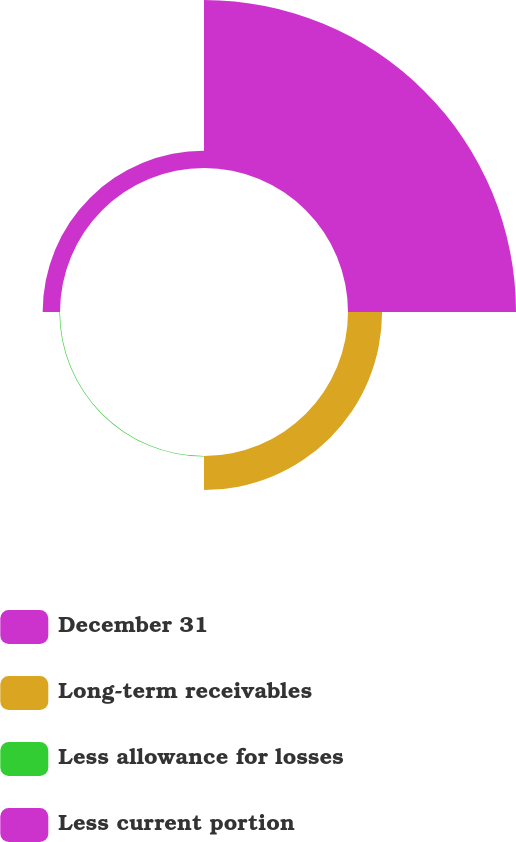Convert chart. <chart><loc_0><loc_0><loc_500><loc_500><pie_chart><fcel>December 31<fcel>Long-term receivables<fcel>Less allowance for losses<fcel>Less current portion<nl><fcel>76.37%<fcel>15.49%<fcel>0.27%<fcel>7.88%<nl></chart> 